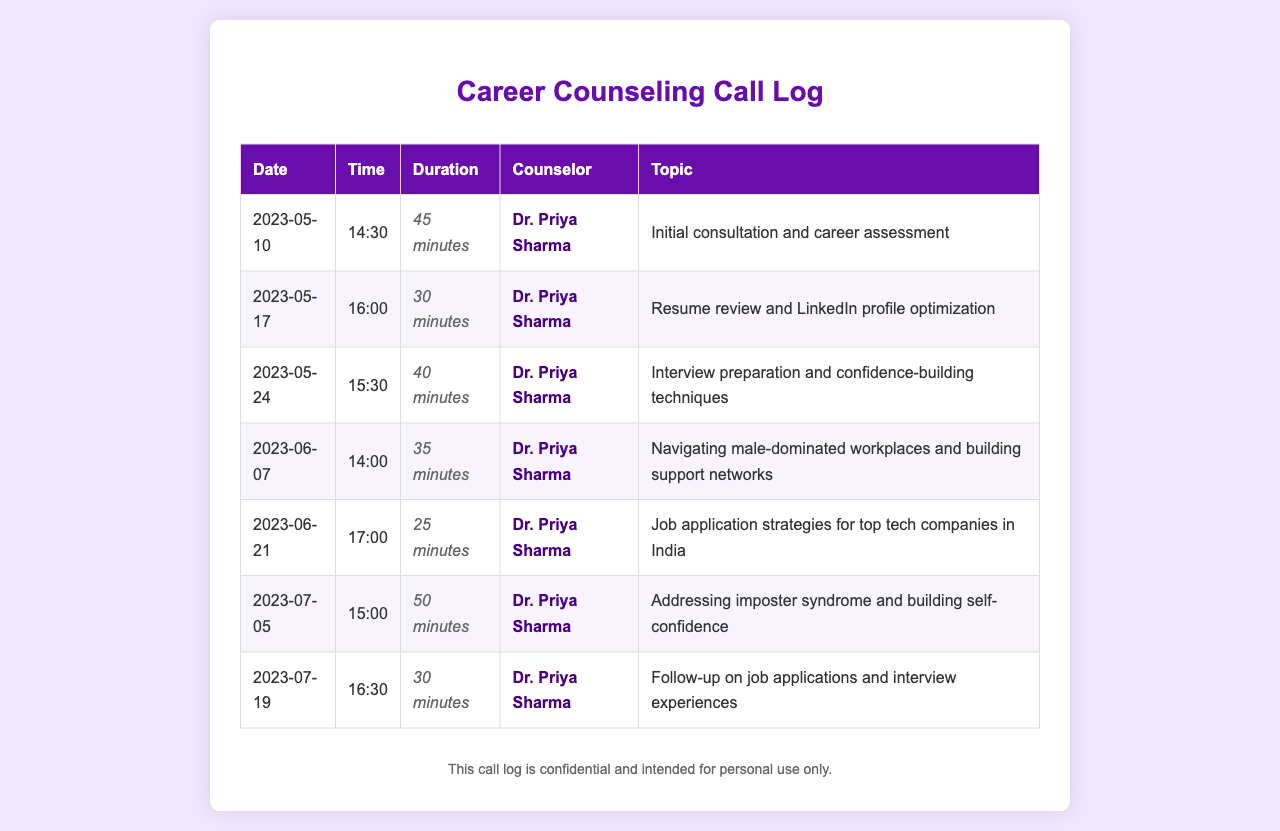What is the name of the counselor? The counselor's name appears in each entry in the log, which is Dr. Priya Sharma.
Answer: Dr. Priya Sharma How many calls were made in total? The total number of calls can be counted from the entries in the document. There are 7 calls listed.
Answer: 7 What was the duration of the call on June 21, 2023? The duration for each call can be found in the respective row; for June 21, it was 25 minutes.
Answer: 25 minutes What is the topic of the call on May 24, 2023? The topic is specified in the entry for that date, which is about interview preparation.
Answer: Interview preparation and confidence-building techniques Which call had the longest duration? To find which call had the longest duration, we can compare the durations listed. The longest was 50 minutes on July 5, 2023.
Answer: 50 minutes What date was the initial consultation held? The date for the initial consultation is clearly stated in the first row of the log as May 10, 2023.
Answer: 2023-05-10 What topic was discussed during the call on June 7, 2023? The topic for June 7 is listed and pertains to navigating male-dominated workplaces.
Answer: Navigating male-dominated workplaces and building support networks 